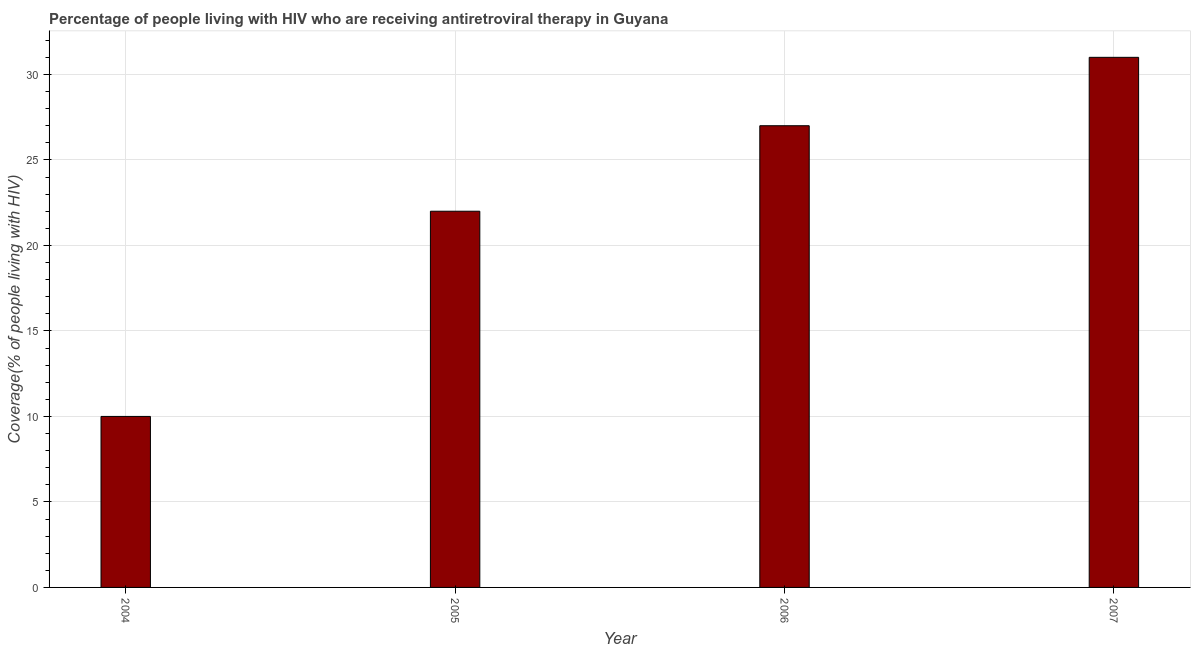What is the title of the graph?
Your answer should be compact. Percentage of people living with HIV who are receiving antiretroviral therapy in Guyana. What is the label or title of the X-axis?
Your answer should be compact. Year. What is the label or title of the Y-axis?
Your answer should be compact. Coverage(% of people living with HIV). What is the difference between the antiretroviral therapy coverage in 2005 and 2006?
Make the answer very short. -5. In how many years, is the antiretroviral therapy coverage greater than 4 %?
Ensure brevity in your answer.  4. Do a majority of the years between 2007 and 2004 (inclusive) have antiretroviral therapy coverage greater than 10 %?
Keep it short and to the point. Yes. What is the ratio of the antiretroviral therapy coverage in 2004 to that in 2007?
Your answer should be compact. 0.32. Is the antiretroviral therapy coverage in 2006 less than that in 2007?
Your answer should be compact. Yes. Is the sum of the antiretroviral therapy coverage in 2004 and 2006 greater than the maximum antiretroviral therapy coverage across all years?
Your answer should be very brief. Yes. What is the difference between the highest and the lowest antiretroviral therapy coverage?
Give a very brief answer. 21. How many years are there in the graph?
Ensure brevity in your answer.  4. What is the difference between two consecutive major ticks on the Y-axis?
Give a very brief answer. 5. What is the Coverage(% of people living with HIV) in 2006?
Provide a succinct answer. 27. What is the Coverage(% of people living with HIV) of 2007?
Give a very brief answer. 31. What is the difference between the Coverage(% of people living with HIV) in 2004 and 2005?
Keep it short and to the point. -12. What is the difference between the Coverage(% of people living with HIV) in 2005 and 2006?
Your response must be concise. -5. What is the difference between the Coverage(% of people living with HIV) in 2005 and 2007?
Make the answer very short. -9. What is the difference between the Coverage(% of people living with HIV) in 2006 and 2007?
Make the answer very short. -4. What is the ratio of the Coverage(% of people living with HIV) in 2004 to that in 2005?
Offer a terse response. 0.46. What is the ratio of the Coverage(% of people living with HIV) in 2004 to that in 2006?
Make the answer very short. 0.37. What is the ratio of the Coverage(% of people living with HIV) in 2004 to that in 2007?
Ensure brevity in your answer.  0.32. What is the ratio of the Coverage(% of people living with HIV) in 2005 to that in 2006?
Offer a very short reply. 0.81. What is the ratio of the Coverage(% of people living with HIV) in 2005 to that in 2007?
Offer a very short reply. 0.71. What is the ratio of the Coverage(% of people living with HIV) in 2006 to that in 2007?
Your answer should be compact. 0.87. 